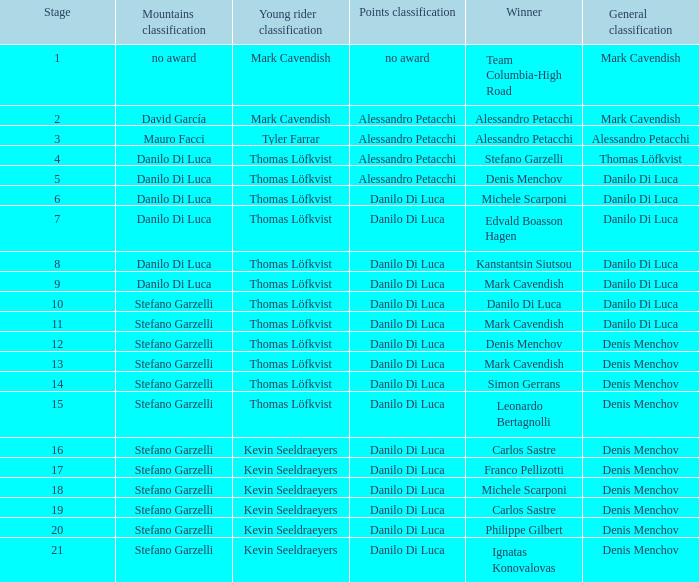When philippe gilbert is the winner who is the points classification? Danilo Di Luca. 